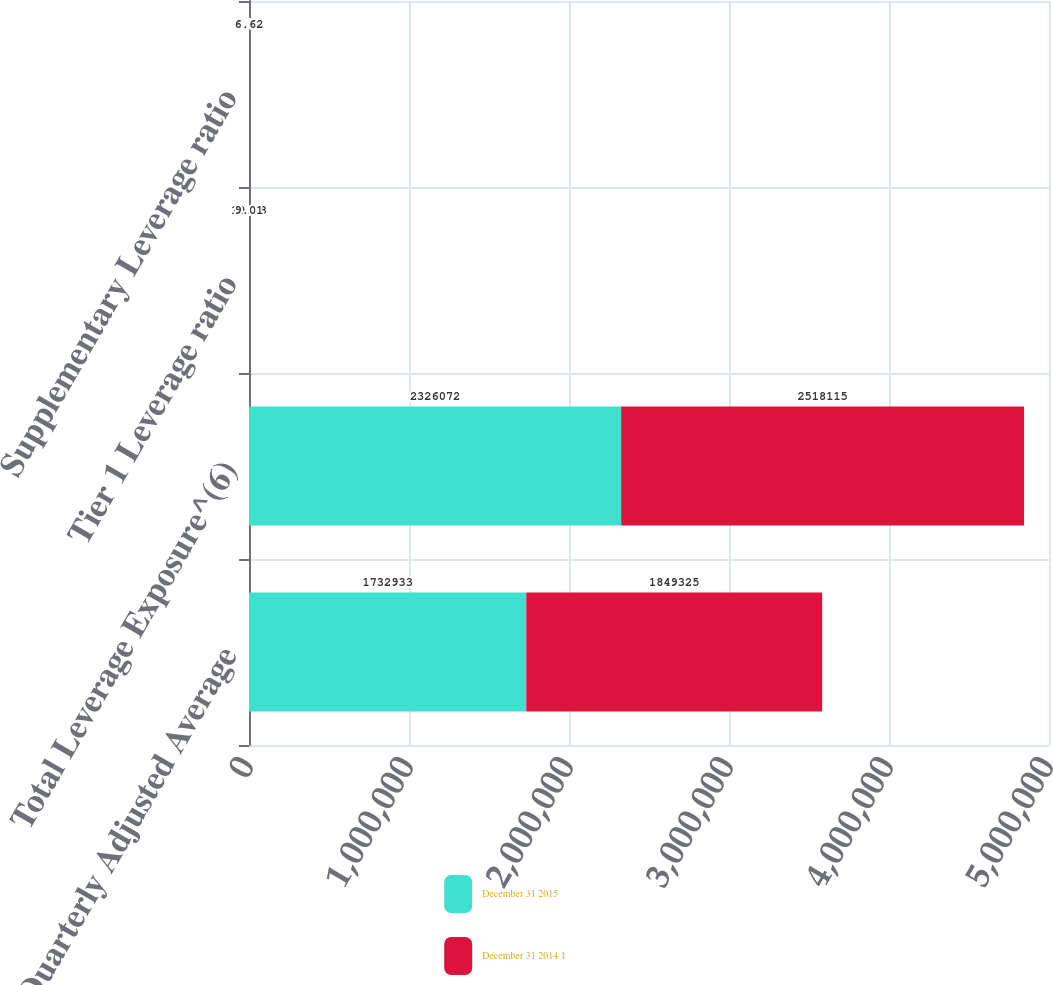<chart> <loc_0><loc_0><loc_500><loc_500><stacked_bar_chart><ecel><fcel>Quarterly Adjusted Average<fcel>Total Leverage Exposure^(6)<fcel>Tier 1 Leverage ratio<fcel>Supplementary Leverage ratio<nl><fcel>December 31 2015<fcel>1.73293e+06<fcel>2.32607e+06<fcel>10.18<fcel>7.58<nl><fcel>December 31 2014 1<fcel>1.84932e+06<fcel>2.51812e+06<fcel>9.01<fcel>6.62<nl></chart> 